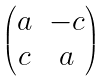<formula> <loc_0><loc_0><loc_500><loc_500>\begin{pmatrix} a & - c \\ c & a \end{pmatrix}</formula> 